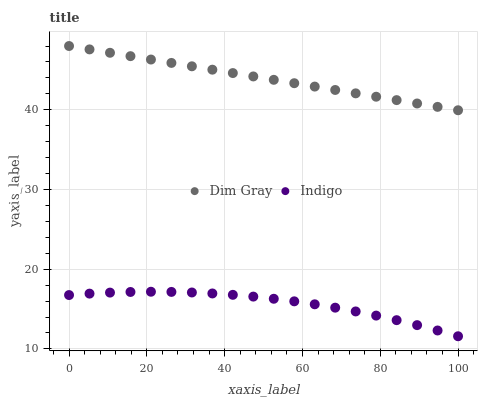Does Indigo have the minimum area under the curve?
Answer yes or no. Yes. Does Dim Gray have the maximum area under the curve?
Answer yes or no. Yes. Does Indigo have the maximum area under the curve?
Answer yes or no. No. Is Dim Gray the smoothest?
Answer yes or no. Yes. Is Indigo the roughest?
Answer yes or no. Yes. Is Indigo the smoothest?
Answer yes or no. No. Does Indigo have the lowest value?
Answer yes or no. Yes. Does Dim Gray have the highest value?
Answer yes or no. Yes. Does Indigo have the highest value?
Answer yes or no. No. Is Indigo less than Dim Gray?
Answer yes or no. Yes. Is Dim Gray greater than Indigo?
Answer yes or no. Yes. Does Indigo intersect Dim Gray?
Answer yes or no. No. 